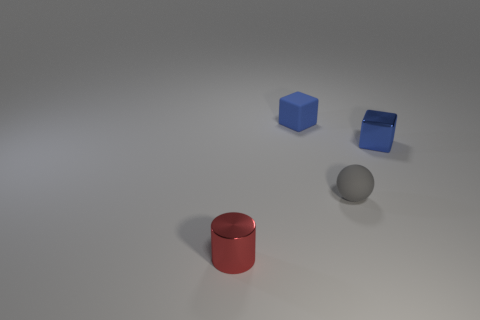Is the metallic block the same color as the small rubber cube?
Ensure brevity in your answer.  Yes. Is there any other thing that has the same shape as the tiny red shiny object?
Your answer should be compact. No. What is the shape of the small thing on the left side of the block that is left of the tiny ball?
Your answer should be compact. Cylinder. What is the shape of the tiny red thing?
Offer a terse response. Cylinder. What number of small objects are either purple matte balls or cylinders?
Your answer should be very brief. 1. There is a blue rubber object that is the same shape as the small blue shiny thing; what is its size?
Your response must be concise. Small. What number of things are both behind the gray rubber thing and to the left of the small matte sphere?
Your answer should be compact. 1. There is a small red metal object; is its shape the same as the blue object to the left of the small gray object?
Your response must be concise. No. Are there more small blue cubes that are behind the tiny blue metal cube than large gray rubber balls?
Make the answer very short. Yes. Are there fewer matte balls that are on the right side of the matte ball than big cyan matte balls?
Offer a terse response. No. 